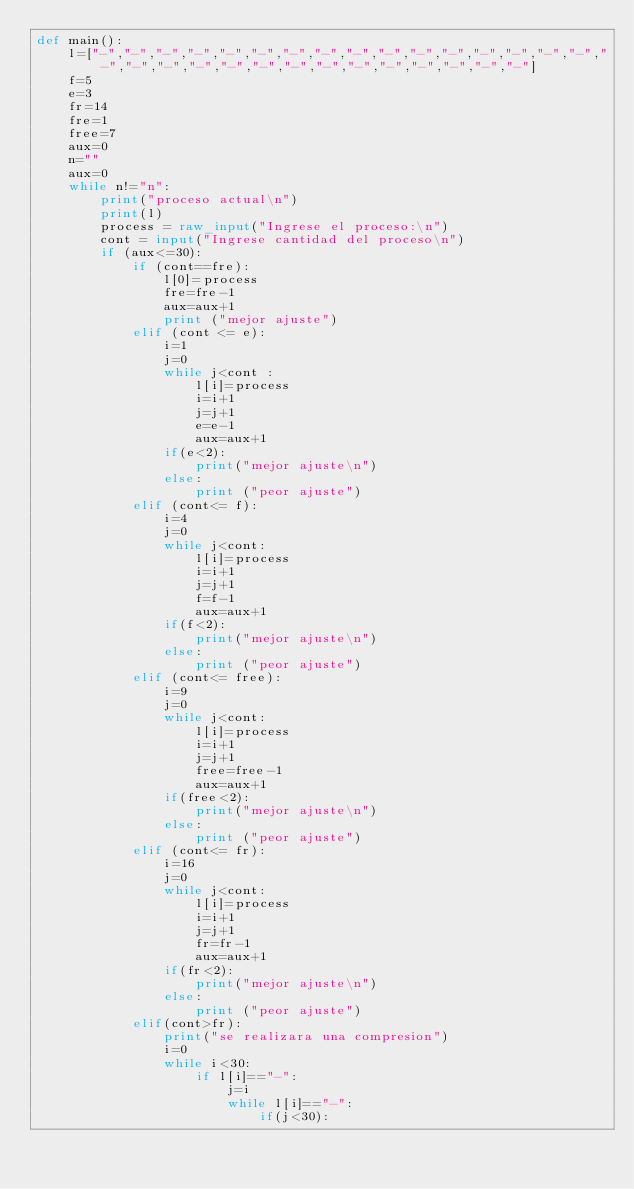Convert code to text. <code><loc_0><loc_0><loc_500><loc_500><_Python_>def main():
	l=["-","-","-","-","-","-","-","-","-","-","-","-","-","-","-","-","-","-","-","-","-","-","-","-","-","-","-","-","-","-"]
	f=5
	e=3
	fr=14
	fre=1
	free=7
	aux=0
	n=""
	aux=0
	while n!="n":
		print("proceso actual\n")
		print(l)
		process = raw_input("Ingrese el proceso:\n")
		cont = input("Ingrese cantidad del proceso\n")
		if (aux<=30):
			if (cont==fre):
				l[0]=process
				fre=fre-1
				aux=aux+1
				print ("mejor ajuste")
			elif (cont <= e):
				i=1 
				j=0
				while j<cont :
					l[i]=process
					i=i+1
					j=j+1
					e=e-1
					aux=aux+1
				if(e<2):
					print("mejor ajuste\n")
				else:
					print ("peor ajuste")
			elif (cont<= f):
				i=4
				j=0
				while j<cont:
					l[i]=process
					i=i+1
					j=j+1
					f=f-1
					aux=aux+1
				if(f<2):
					print("mejor ajuste\n")
				else:
					print ("peor ajuste")
			elif (cont<= free):
				i=9
				j=0
				while j<cont:
					l[i]=process
					i=i+1
					j=j+1
					free=free-1
					aux=aux+1
				if(free<2):
					print("mejor ajuste\n")
				else:
					print ("peor ajuste")
			elif (cont<= fr):
				i=16
				j=0
				while j<cont:
					l[i]=process
					i=i+1
					j=j+1
					fr=fr-1
					aux=aux+1
				if(fr<2):
					print("mejor ajuste\n")
				else:
					print ("peor ajuste")
			elif(cont>fr):
				print("se realizara una compresion")
				i=0
				while i<30:
					if l[i]=="-":
						j=i
						while l[i]=="-":
							if(j<30):</code> 